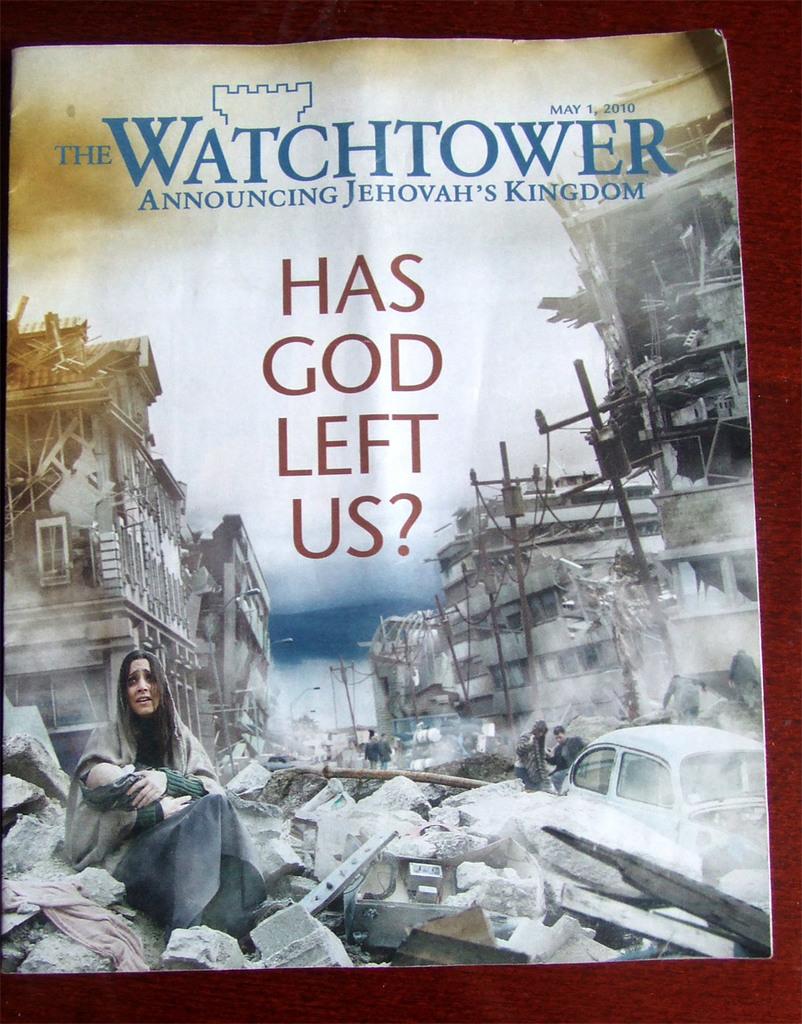What is the date of publication of the pamphlet?
Provide a succinct answer. May 1, 2010. What is the title of the book?
Make the answer very short. Has god left us?. 